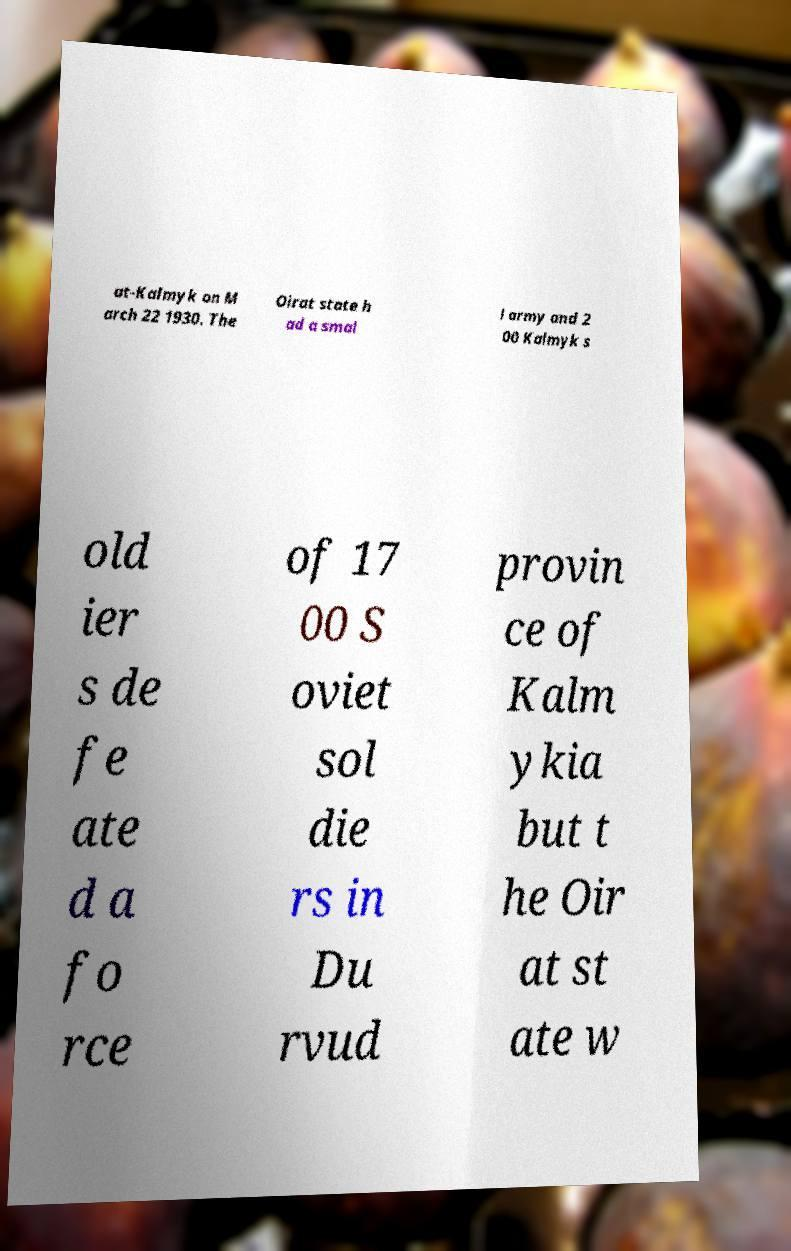Could you assist in decoding the text presented in this image and type it out clearly? at-Kalmyk on M arch 22 1930. The Oirat state h ad a smal l army and 2 00 Kalmyk s old ier s de fe ate d a fo rce of 17 00 S oviet sol die rs in Du rvud provin ce of Kalm ykia but t he Oir at st ate w 